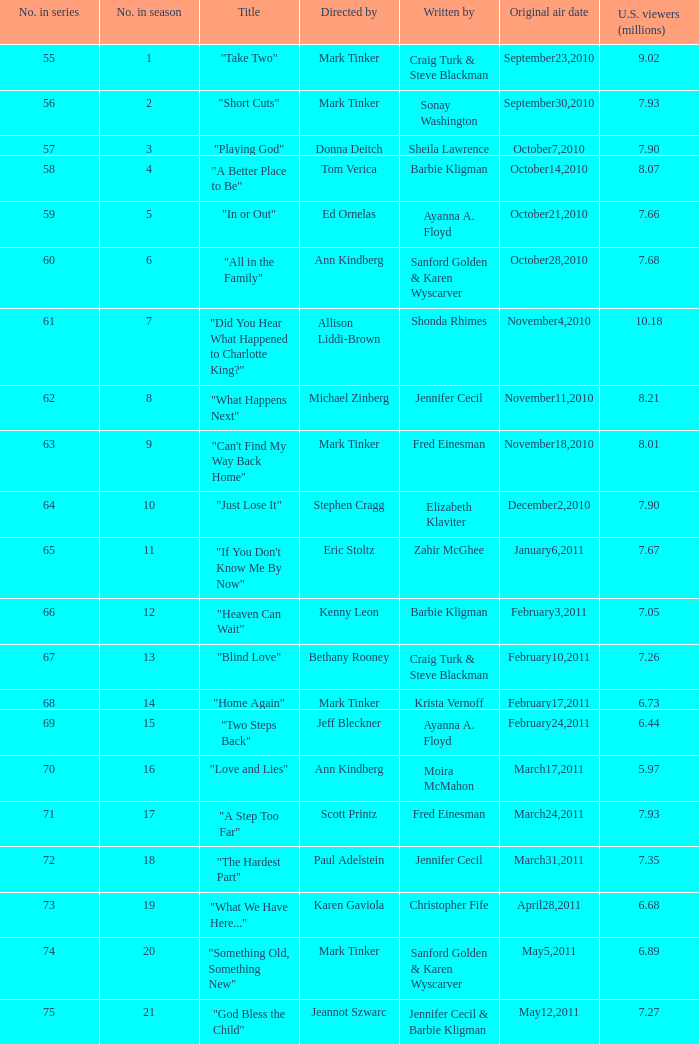What number episode in the season was directed by Paul Adelstein?  18.0. 